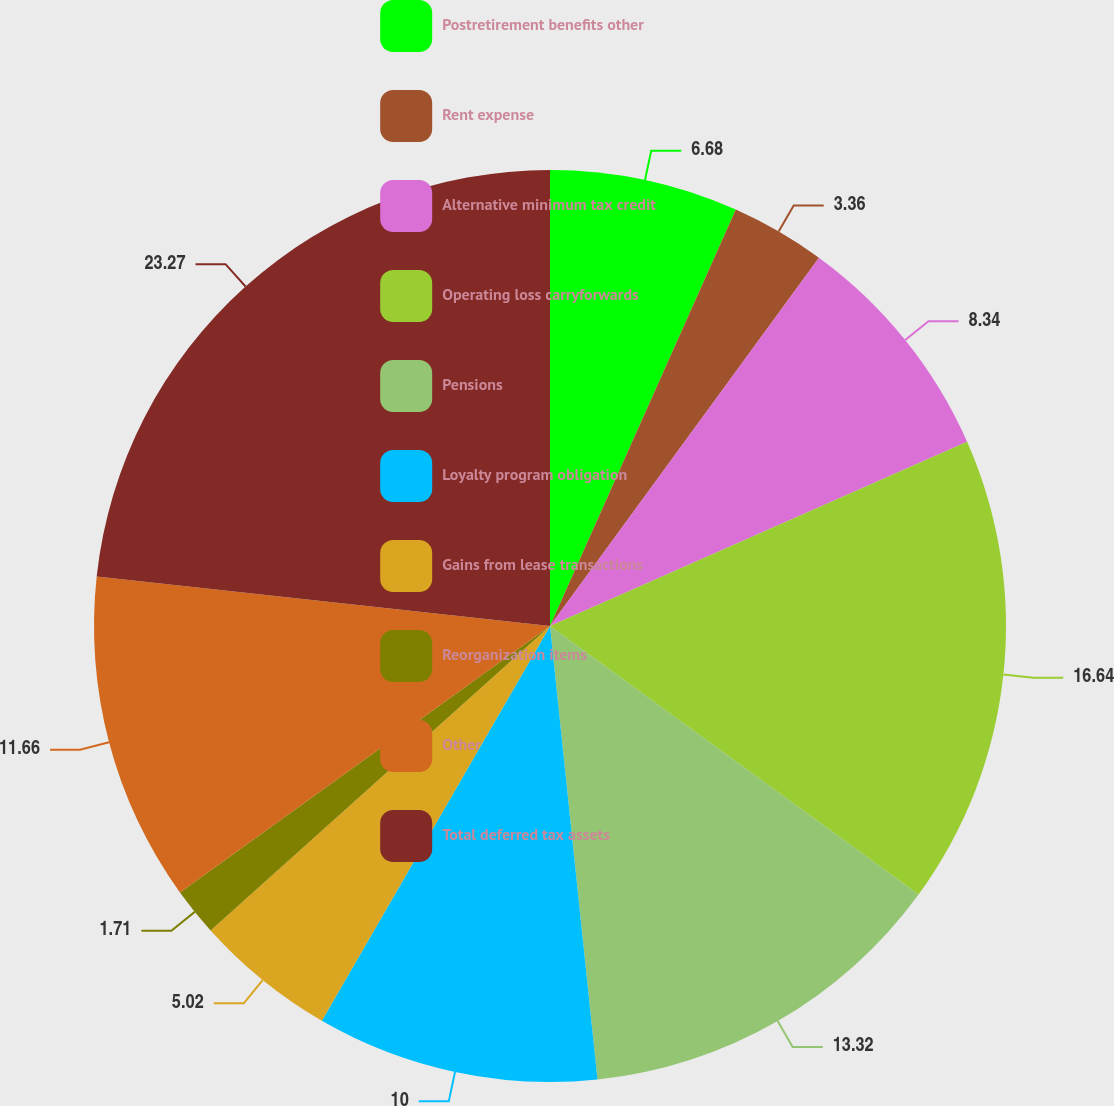Convert chart. <chart><loc_0><loc_0><loc_500><loc_500><pie_chart><fcel>Postretirement benefits other<fcel>Rent expense<fcel>Alternative minimum tax credit<fcel>Operating loss carryforwards<fcel>Pensions<fcel>Loyalty program obligation<fcel>Gains from lease transactions<fcel>Reorganization items<fcel>Other<fcel>Total deferred tax assets<nl><fcel>6.68%<fcel>3.36%<fcel>8.34%<fcel>16.64%<fcel>13.32%<fcel>10.0%<fcel>5.02%<fcel>1.71%<fcel>11.66%<fcel>23.27%<nl></chart> 